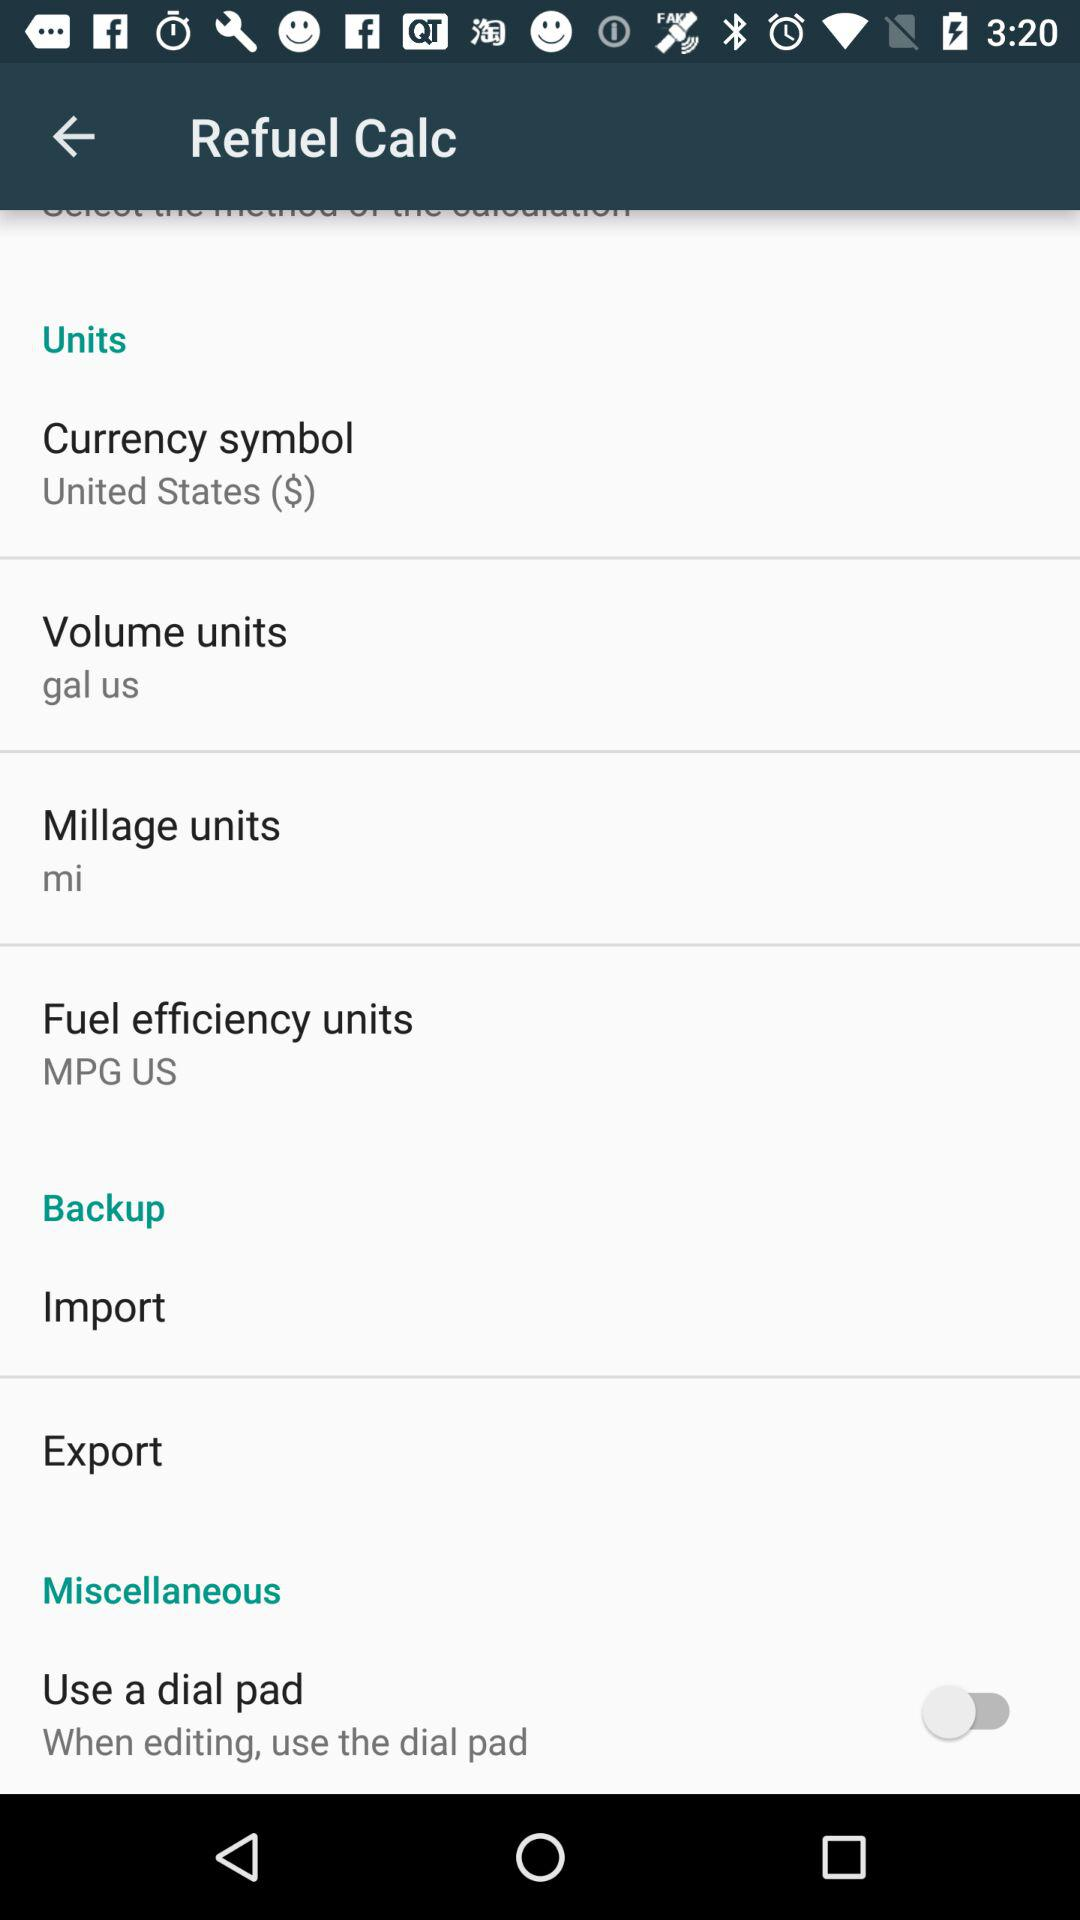What's the country name and currency symbol? The country name is the United States and the currency symbol is $. 